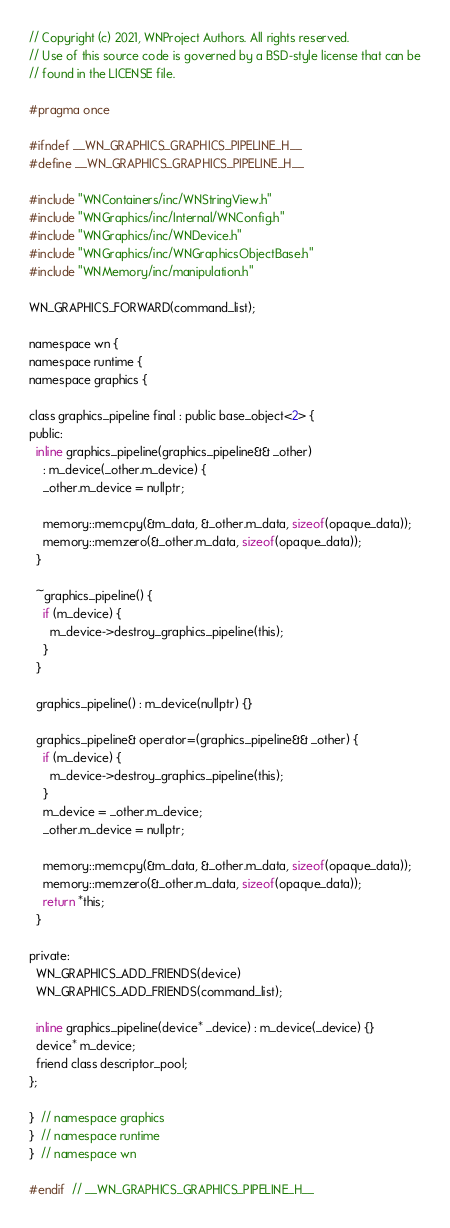Convert code to text. <code><loc_0><loc_0><loc_500><loc_500><_C_>// Copyright (c) 2021, WNProject Authors. All rights reserved.
// Use of this source code is governed by a BSD-style license that can be
// found in the LICENSE file.

#pragma once

#ifndef __WN_GRAPHICS_GRAPHICS_PIPELINE_H__
#define __WN_GRAPHICS_GRAPHICS_PIPELINE_H__

#include "WNContainers/inc/WNStringView.h"
#include "WNGraphics/inc/Internal/WNConfig.h"
#include "WNGraphics/inc/WNDevice.h"
#include "WNGraphics/inc/WNGraphicsObjectBase.h"
#include "WNMemory/inc/manipulation.h"

WN_GRAPHICS_FORWARD(command_list);

namespace wn {
namespace runtime {
namespace graphics {

class graphics_pipeline final : public base_object<2> {
public:
  inline graphics_pipeline(graphics_pipeline&& _other)
    : m_device(_other.m_device) {
    _other.m_device = nullptr;

    memory::memcpy(&m_data, &_other.m_data, sizeof(opaque_data));
    memory::memzero(&_other.m_data, sizeof(opaque_data));
  }

  ~graphics_pipeline() {
    if (m_device) {
      m_device->destroy_graphics_pipeline(this);
    }
  }

  graphics_pipeline() : m_device(nullptr) {}

  graphics_pipeline& operator=(graphics_pipeline&& _other) {
    if (m_device) {
      m_device->destroy_graphics_pipeline(this);
    }
    m_device = _other.m_device;
    _other.m_device = nullptr;

    memory::memcpy(&m_data, &_other.m_data, sizeof(opaque_data));
    memory::memzero(&_other.m_data, sizeof(opaque_data));
    return *this;
  }

private:
  WN_GRAPHICS_ADD_FRIENDS(device)
  WN_GRAPHICS_ADD_FRIENDS(command_list);

  inline graphics_pipeline(device* _device) : m_device(_device) {}
  device* m_device;
  friend class descriptor_pool;
};

}  // namespace graphics
}  // namespace runtime
}  // namespace wn

#endif  // __WN_GRAPHICS_GRAPHICS_PIPELINE_H__
</code> 